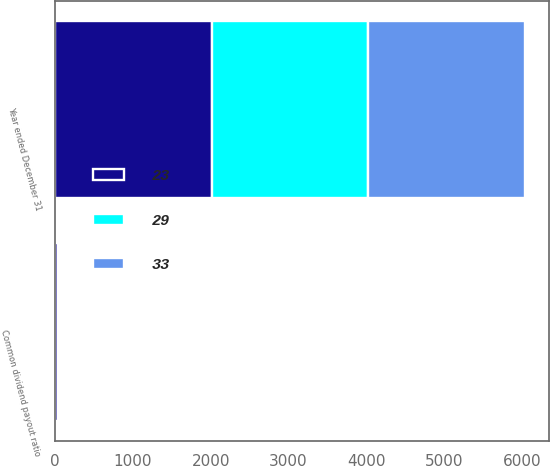Convert chart to OTSL. <chart><loc_0><loc_0><loc_500><loc_500><stacked_bar_chart><ecel><fcel>Year ended December 31<fcel>Common dividend payout ratio<nl><fcel>33<fcel>2014<fcel>29<nl><fcel>23<fcel>2013<fcel>33<nl><fcel>29<fcel>2012<fcel>23<nl></chart> 